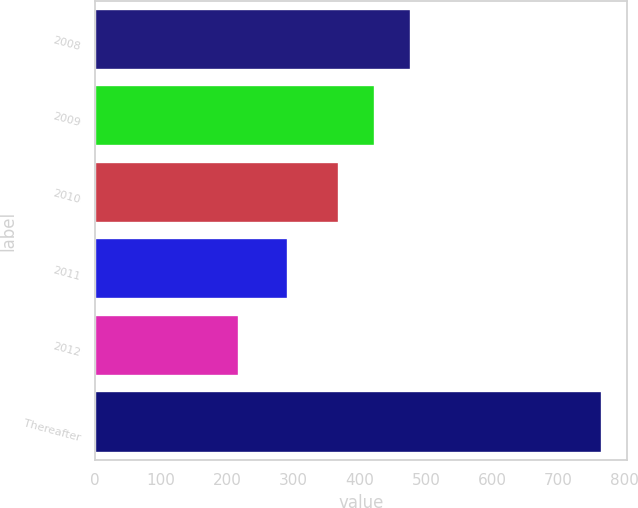Convert chart to OTSL. <chart><loc_0><loc_0><loc_500><loc_500><bar_chart><fcel>2008<fcel>2009<fcel>2010<fcel>2011<fcel>2012<fcel>Thereafter<nl><fcel>477.8<fcel>422.9<fcel>368<fcel>292<fcel>217<fcel>766<nl></chart> 